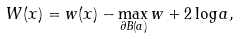<formula> <loc_0><loc_0><loc_500><loc_500>W ( x ) = w ( x ) - \max _ { \partial B ( a ) } w + 2 \log a ,</formula> 